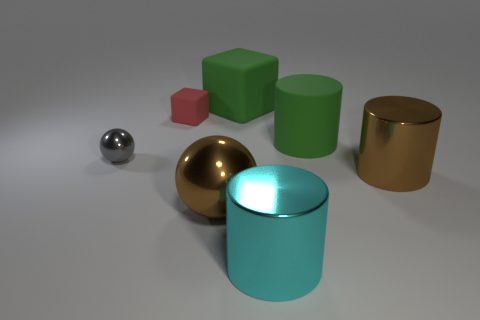How many things are brown things right of the large green matte cylinder or big shiny objects that are to the right of the large rubber cylinder?
Give a very brief answer. 1. Do the green matte block and the cylinder that is behind the gray shiny object have the same size?
Provide a short and direct response. Yes. Do the big cylinder that is on the right side of the green matte cylinder and the small object that is to the right of the small shiny thing have the same material?
Keep it short and to the point. No. Are there the same number of large metal spheres that are in front of the large cyan object and large brown metallic things that are to the left of the gray metallic ball?
Your answer should be compact. Yes. How many big rubber objects have the same color as the big block?
Give a very brief answer. 1. What is the material of the big object that is the same color as the large sphere?
Keep it short and to the point. Metal. How many matte things are brown cylinders or small things?
Your response must be concise. 1. Does the rubber thing behind the red matte block have the same shape as the green object that is in front of the red block?
Keep it short and to the point. No. What number of cyan metallic things are behind the gray ball?
Your response must be concise. 0. Is there a small purple thing that has the same material as the large brown cylinder?
Provide a short and direct response. No. 